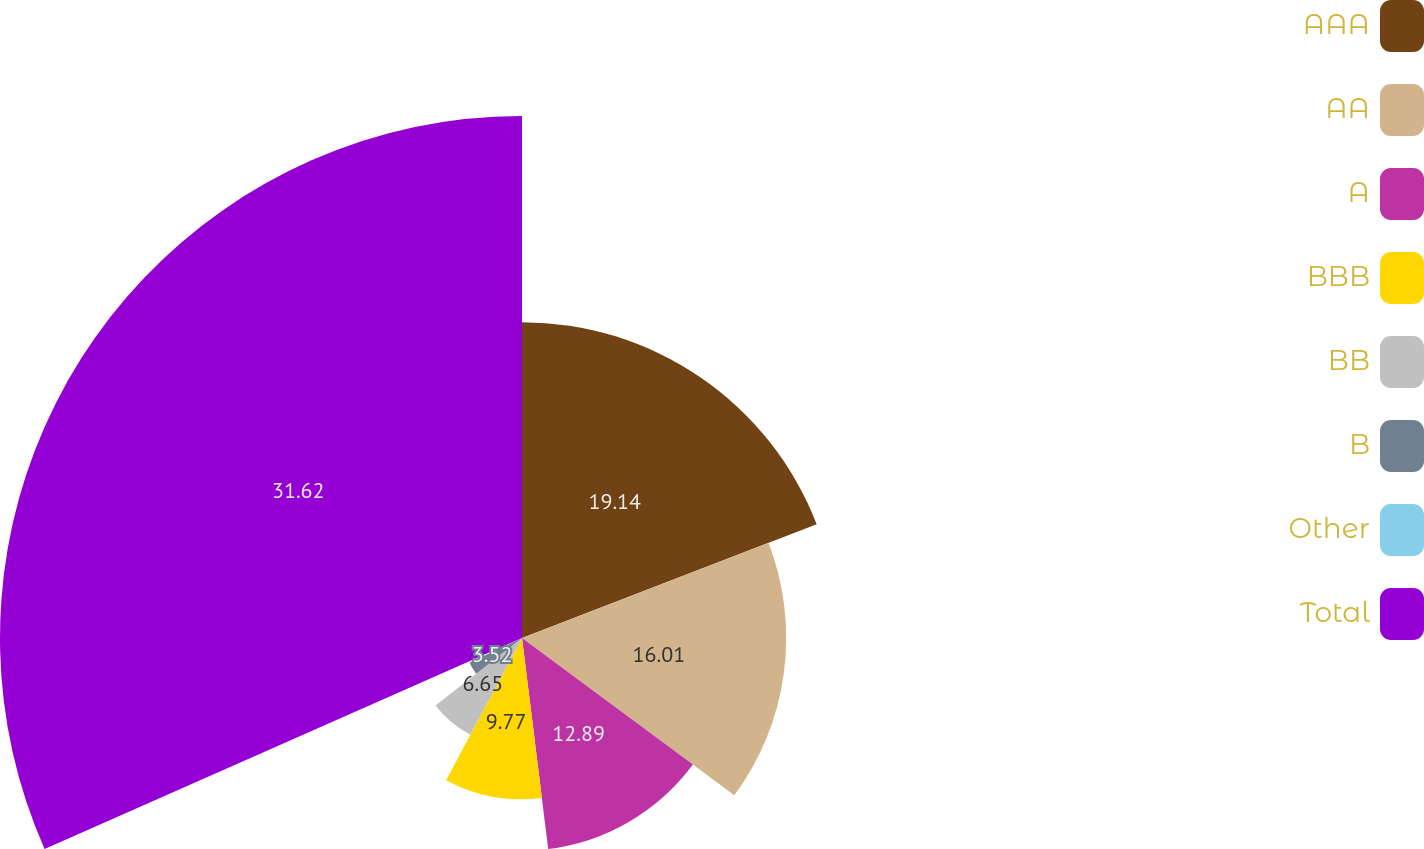Convert chart to OTSL. <chart><loc_0><loc_0><loc_500><loc_500><pie_chart><fcel>AAA<fcel>AA<fcel>A<fcel>BBB<fcel>BB<fcel>B<fcel>Other<fcel>Total<nl><fcel>19.14%<fcel>16.01%<fcel>12.89%<fcel>9.77%<fcel>6.65%<fcel>3.52%<fcel>0.4%<fcel>31.63%<nl></chart> 